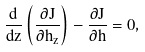Convert formula to latex. <formula><loc_0><loc_0><loc_500><loc_500>\frac { d } { d z } \left ( \frac { \partial J } { \partial h _ { z } } \right ) - \frac { \partial J } { \partial h } = 0 ,</formula> 